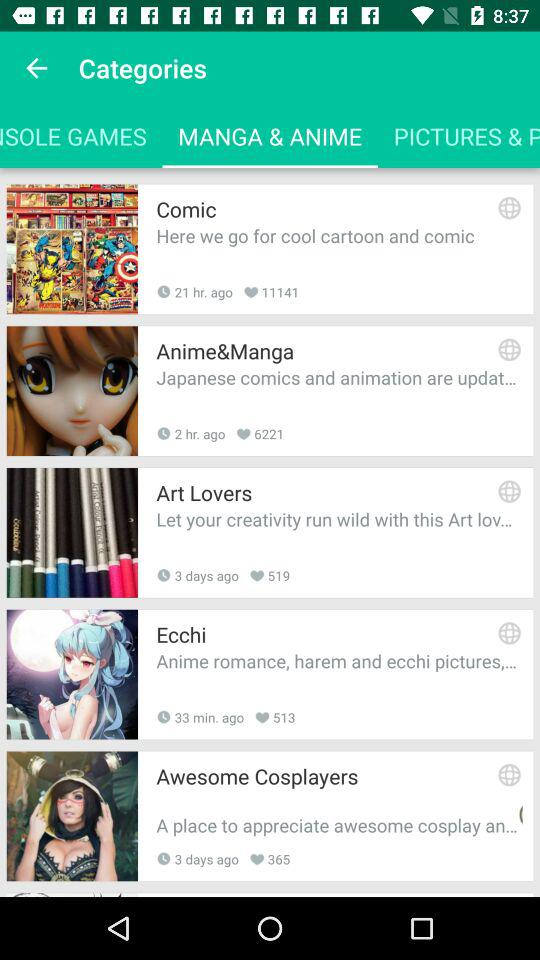What was posted 33 minutes ago? 33 minutes ago, "Ecchi" was posted. 